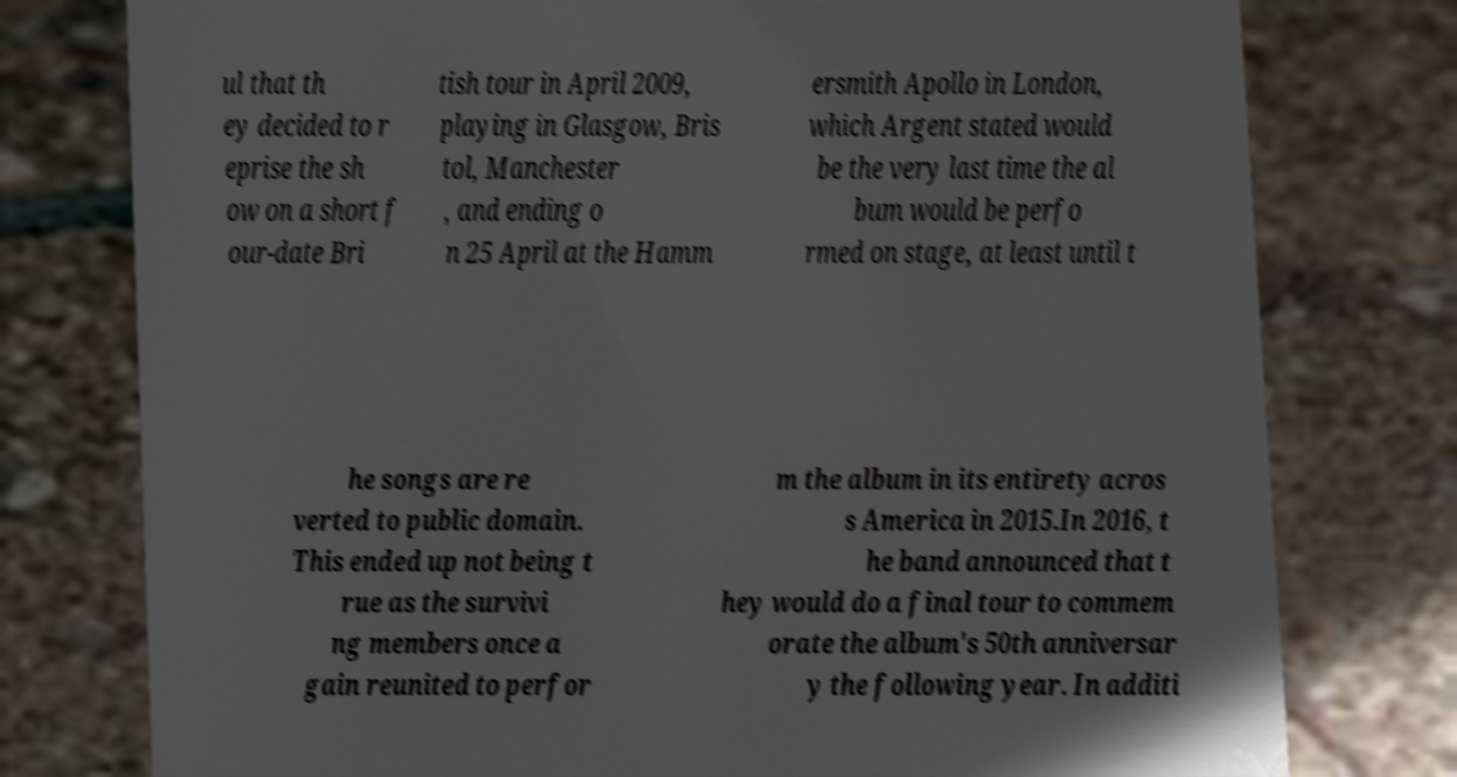What messages or text are displayed in this image? I need them in a readable, typed format. ul that th ey decided to r eprise the sh ow on a short f our-date Bri tish tour in April 2009, playing in Glasgow, Bris tol, Manchester , and ending o n 25 April at the Hamm ersmith Apollo in London, which Argent stated would be the very last time the al bum would be perfo rmed on stage, at least until t he songs are re verted to public domain. This ended up not being t rue as the survivi ng members once a gain reunited to perfor m the album in its entirety acros s America in 2015.In 2016, t he band announced that t hey would do a final tour to commem orate the album's 50th anniversar y the following year. In additi 